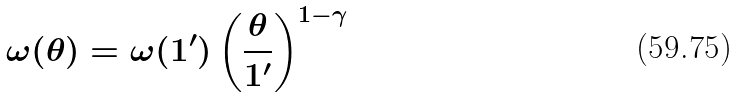<formula> <loc_0><loc_0><loc_500><loc_500>\omega ( \theta ) = \omega ( 1 ^ { \prime } ) \left ( \frac { \theta } { 1 ^ { \prime } } \right ) ^ { 1 - \gamma }</formula> 